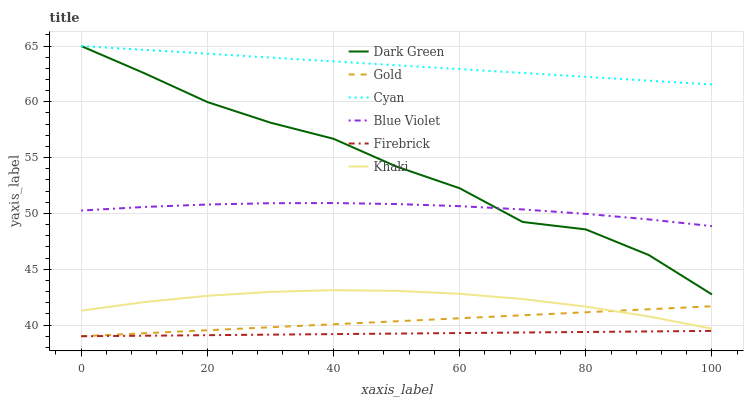Does Firebrick have the minimum area under the curve?
Answer yes or no. Yes. Does Cyan have the maximum area under the curve?
Answer yes or no. Yes. Does Gold have the minimum area under the curve?
Answer yes or no. No. Does Gold have the maximum area under the curve?
Answer yes or no. No. Is Cyan the smoothest?
Answer yes or no. Yes. Is Dark Green the roughest?
Answer yes or no. Yes. Is Gold the smoothest?
Answer yes or no. No. Is Gold the roughest?
Answer yes or no. No. Does Gold have the lowest value?
Answer yes or no. Yes. Does Cyan have the lowest value?
Answer yes or no. No. Does Dark Green have the highest value?
Answer yes or no. Yes. Does Gold have the highest value?
Answer yes or no. No. Is Gold less than Blue Violet?
Answer yes or no. Yes. Is Cyan greater than Khaki?
Answer yes or no. Yes. Does Dark Green intersect Blue Violet?
Answer yes or no. Yes. Is Dark Green less than Blue Violet?
Answer yes or no. No. Is Dark Green greater than Blue Violet?
Answer yes or no. No. Does Gold intersect Blue Violet?
Answer yes or no. No. 